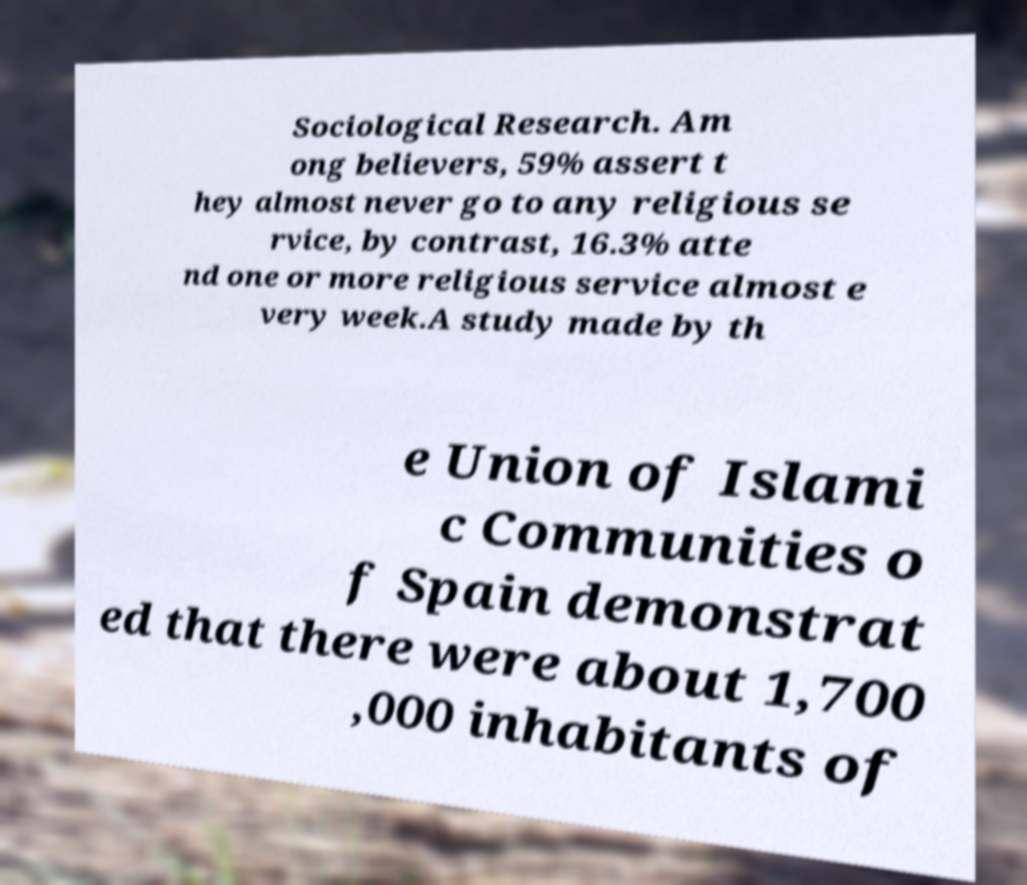What messages or text are displayed in this image? I need them in a readable, typed format. Sociological Research. Am ong believers, 59% assert t hey almost never go to any religious se rvice, by contrast, 16.3% atte nd one or more religious service almost e very week.A study made by th e Union of Islami c Communities o f Spain demonstrat ed that there were about 1,700 ,000 inhabitants of 